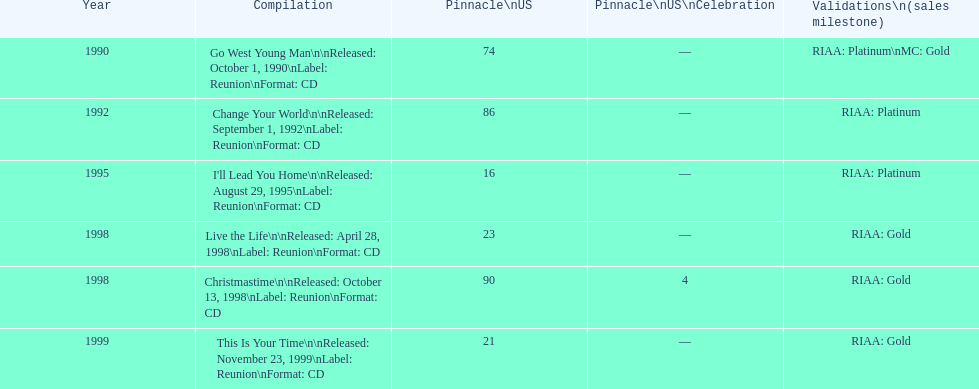The oldest year listed is what? 1990. 